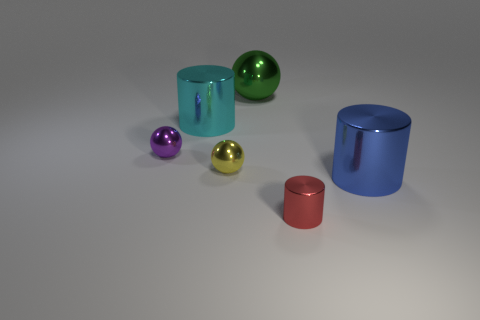What is the shape of the object that is left of the yellow sphere and in front of the large cyan thing?
Give a very brief answer. Sphere. What is the color of the tiny cylinder that is the same material as the large ball?
Provide a succinct answer. Red. Are there an equal number of yellow metallic balls that are right of the big ball and green rubber cylinders?
Make the answer very short. Yes. The cyan shiny object that is the same size as the blue metal object is what shape?
Offer a terse response. Cylinder. What number of other objects are the same shape as the blue metal thing?
Make the answer very short. 2. There is a blue cylinder; is it the same size as the shiny object in front of the large blue shiny cylinder?
Make the answer very short. No. How many things are shiny objects to the left of the tiny red object or small red rubber spheres?
Provide a short and direct response. 4. What is the shape of the purple thing behind the tiny yellow metal thing?
Ensure brevity in your answer.  Sphere. Are there an equal number of big metallic things in front of the small yellow shiny object and big green objects that are to the left of the tiny red metal cylinder?
Provide a short and direct response. Yes. There is a object that is both to the right of the small yellow metal ball and to the left of the red cylinder; what is its color?
Keep it short and to the point. Green. 